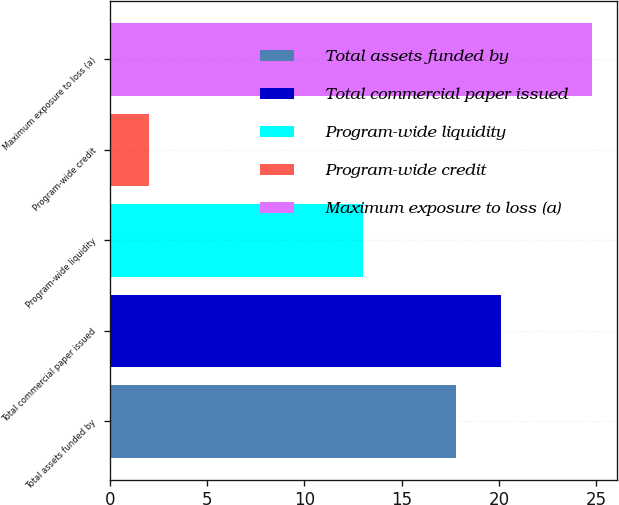Convert chart to OTSL. <chart><loc_0><loc_0><loc_500><loc_500><bar_chart><fcel>Total assets funded by<fcel>Total commercial paper issued<fcel>Program-wide liquidity<fcel>Program-wide credit<fcel>Maximum exposure to loss (a)<nl><fcel>17.8<fcel>20.08<fcel>13<fcel>2<fcel>24.8<nl></chart> 